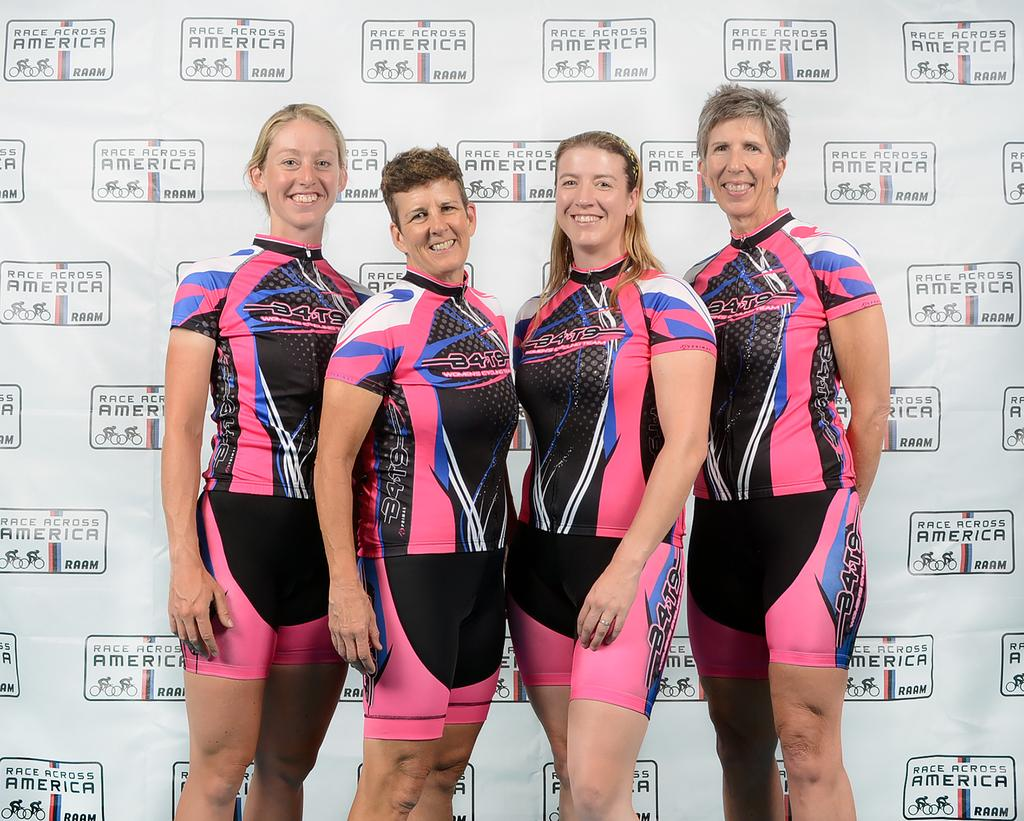<image>
Provide a brief description of the given image. The women here are taking part in the Race Across America 